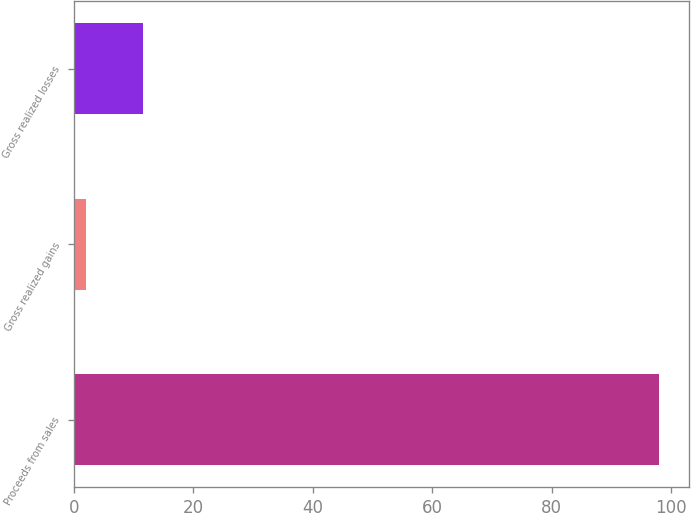Convert chart. <chart><loc_0><loc_0><loc_500><loc_500><bar_chart><fcel>Proceeds from sales<fcel>Gross realized gains<fcel>Gross realized losses<nl><fcel>98<fcel>2<fcel>11.6<nl></chart> 